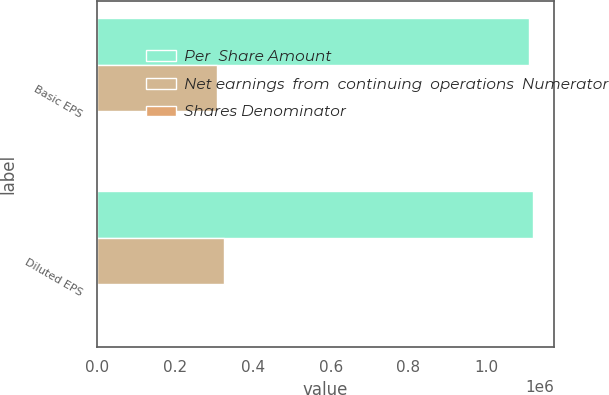<chart> <loc_0><loc_0><loc_500><loc_500><stacked_bar_chart><ecel><fcel>Basic EPS<fcel>Diluted EPS<nl><fcel>Per  Share Amount<fcel>1.10921e+06<fcel>1.11855e+06<nl><fcel>Net earnings  from  continuing  operations  Numerator<fcel>307984<fcel>325251<nl><fcel>Shares Denominator<fcel>3.6<fcel>3.44<nl></chart> 